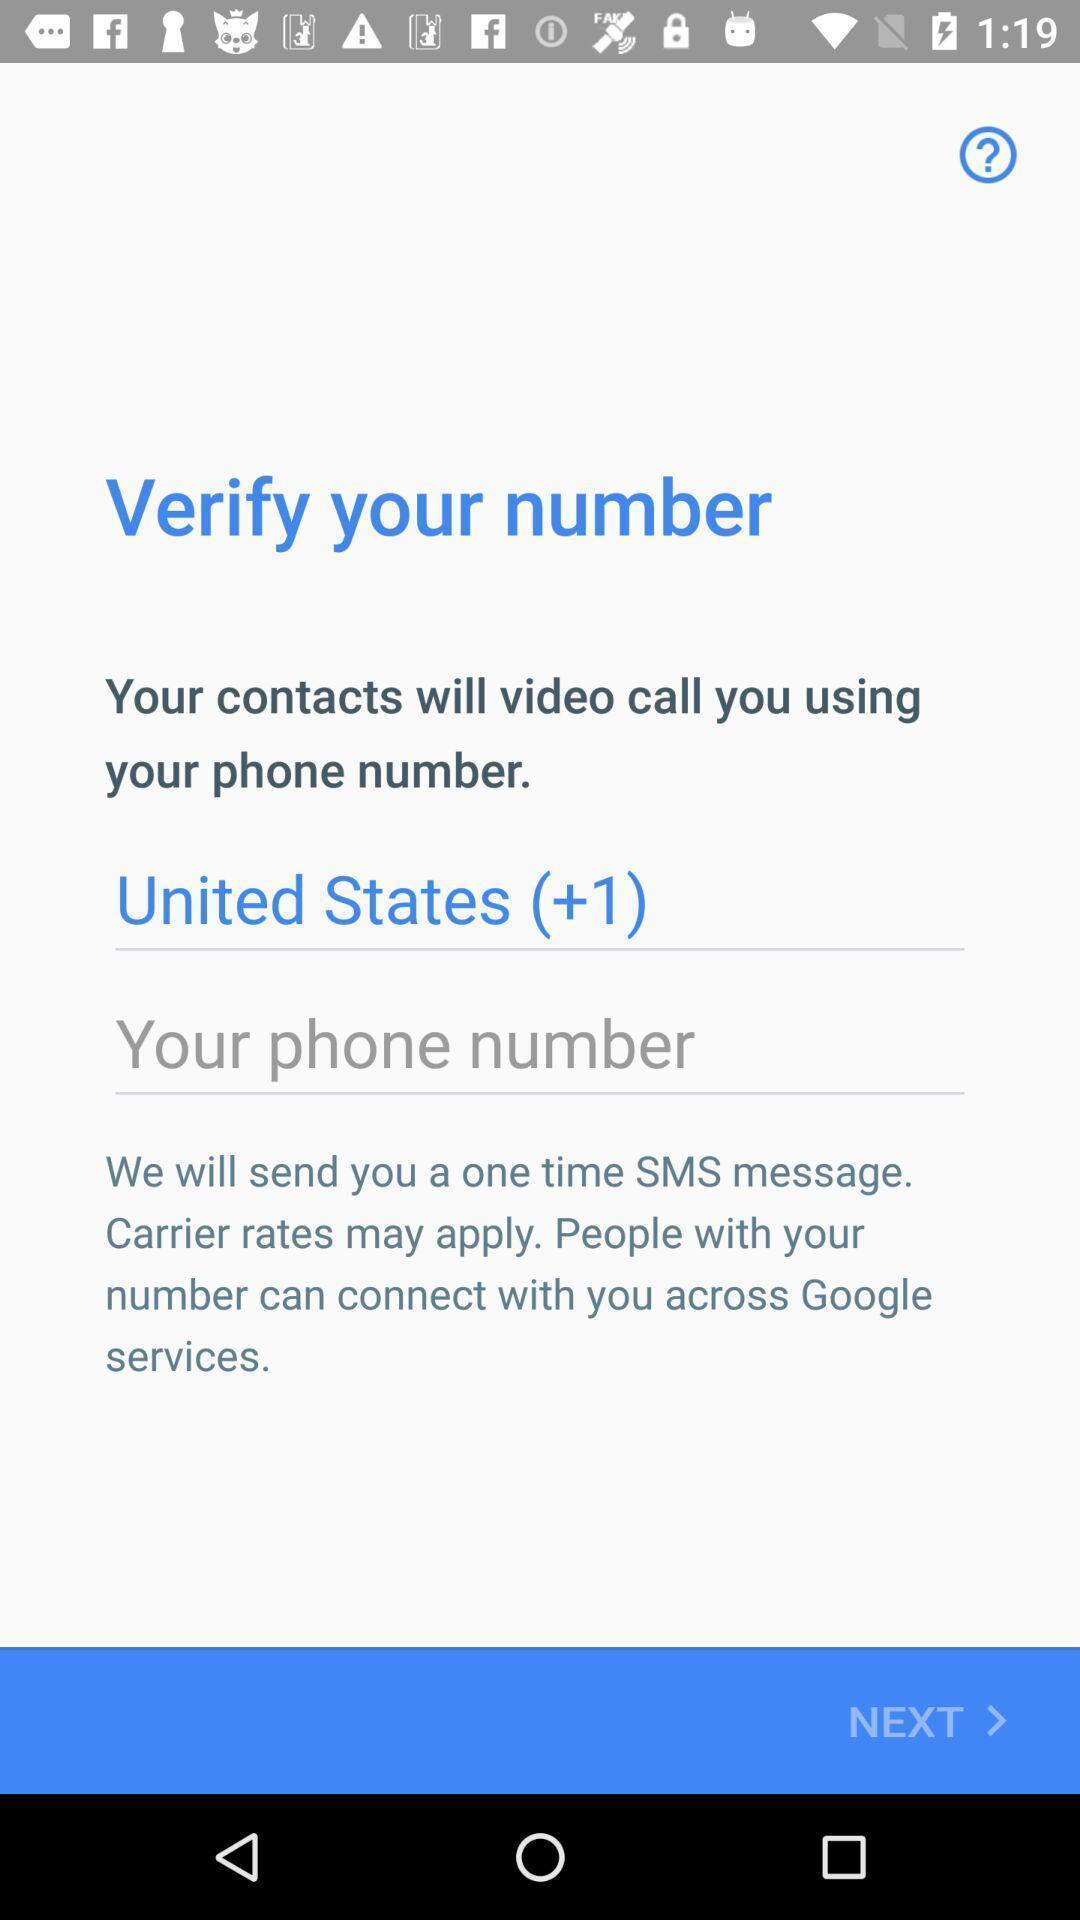Provide a description of this screenshot. Page is showing verify your number. 